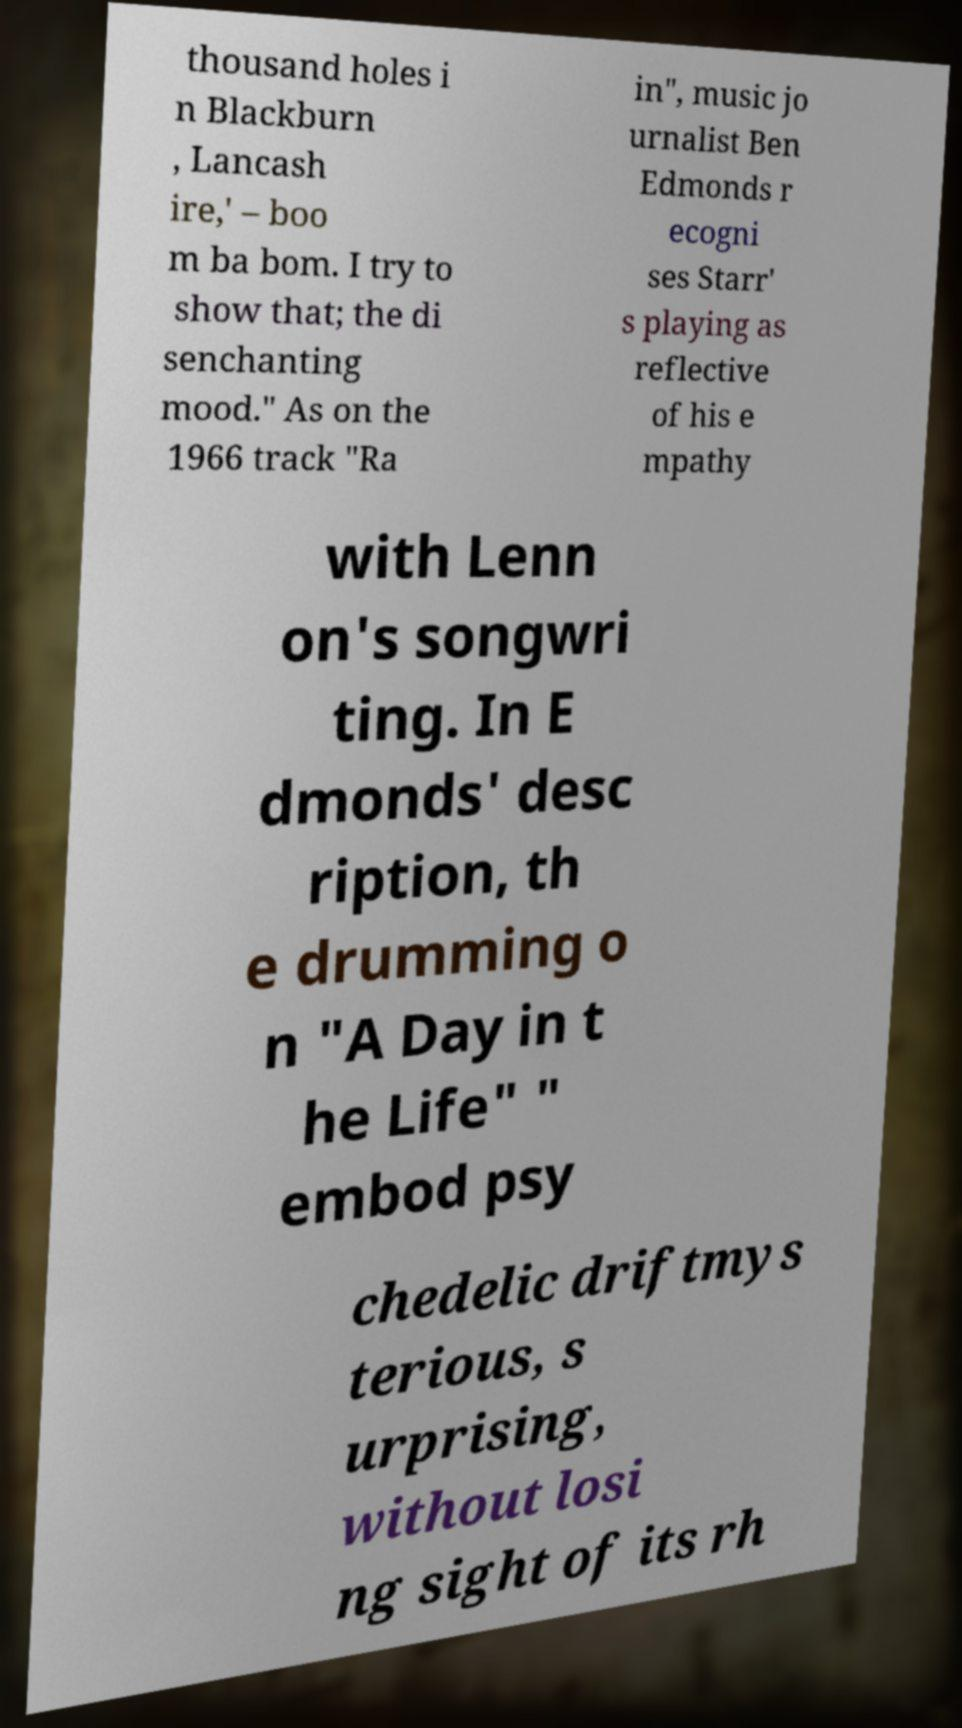Could you assist in decoding the text presented in this image and type it out clearly? thousand holes i n Blackburn , Lancash ire,' – boo m ba bom. I try to show that; the di senchanting mood." As on the 1966 track "Ra in", music jo urnalist Ben Edmonds r ecogni ses Starr' s playing as reflective of his e mpathy with Lenn on's songwri ting. In E dmonds' desc ription, th e drumming o n "A Day in t he Life" " embod psy chedelic driftmys terious, s urprising, without losi ng sight of its rh 